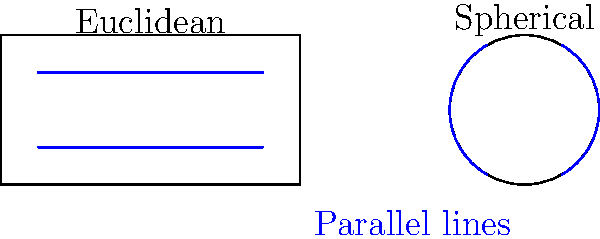In the diagram above, parallel lines are shown in both Euclidean and spherical geometries. From an IT security perspective, how might the differences between these geometries impact the design of encryption algorithms or network topologies? Provide a specific example of how non-Euclidean geometry could potentially enhance or complicate a cybersecurity solution. To answer this question, let's break down the key differences and their potential implications:

1. Euclidean geometry:
   - Parallel lines never intersect
   - Consistent distance between parallel lines
   - Sum of angles in a triangle is always 180°

2. Spherical geometry:
   - "Parallel" lines (great circles) always intersect at two antipodal points
   - Distance between "parallel" lines varies
   - Sum of angles in a triangle is always greater than 180°

Implications for IT security:

1. Encryption algorithms:
   - Traditional encryption often relies on properties of Euclidean space (e.g., RSA using properties of prime numbers in a flat space)
   - Non-Euclidean geometry could introduce new mathematical relationships for cryptographic functions

2. Network topologies:
   - Euclidean-based network designs assume straight-line connections
   - Spherical geometry could model global networks more accurately, accounting for Earth's curvature

3. Data visualization:
   - Security analytics often use Euclidean space for data representation
   - Non-Euclidean visualizations could reveal hidden patterns in complex datasets

Example: Enhancing cybersecurity with non-Euclidean geometry

A specific application could be in quantum key distribution (QKD) systems. Current QKD protocols often assume a flat, Euclidean space for photon transmission. However, in long-distance, satellite-based QKD, the curvature of the Earth becomes significant. Using spherical geometry to model photon paths could:

1. Improve key generation rates by accounting for gravitational effects on photon trajectories
2. Enhance security by making it harder for adversaries to intercept photons, as their paths are no longer straight lines
3. Optimize satellite positioning for maximum coverage and minimal signal degradation

This application demonstrates how non-Euclidean geometry could potentially enhance the security and efficiency of quantum communication systems, addressing real-world constraints that Euclidean models might overlook.
Answer: Non-Euclidean geometry in QKD could improve key generation, enhance security, and optimize satellite positioning by accurately modeling Earth's curvature for long-distance quantum communication. 